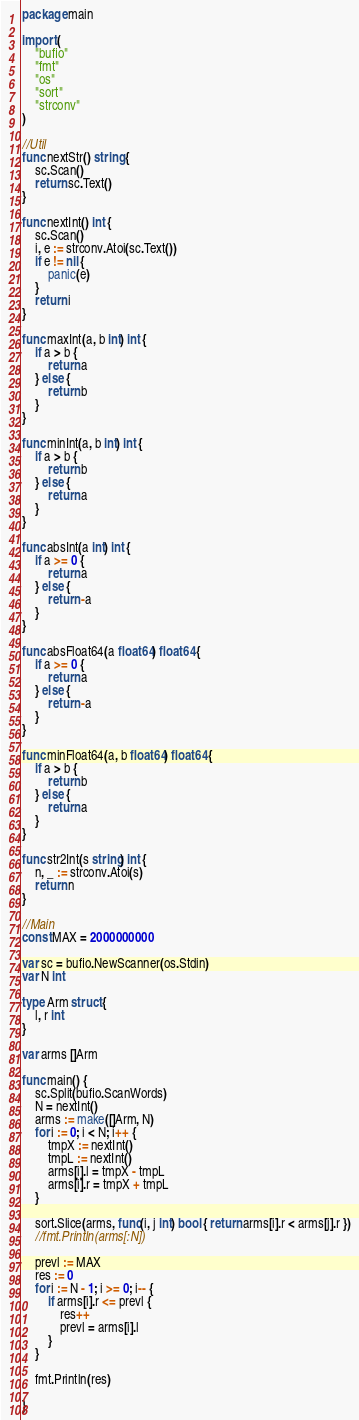<code> <loc_0><loc_0><loc_500><loc_500><_Go_>package main

import (
	"bufio"
	"fmt"
	"os"
	"sort"
	"strconv"
)

//Util
func nextStr() string {
	sc.Scan()
	return sc.Text()
}

func nextInt() int {
	sc.Scan()
	i, e := strconv.Atoi(sc.Text())
	if e != nil {
		panic(e)
	}
	return i
}

func maxInt(a, b int) int {
	if a > b {
		return a
	} else {
		return b
	}
}

func minInt(a, b int) int {
	if a > b {
		return b
	} else {
		return a
	}
}

func absInt(a int) int {
	if a >= 0 {
		return a
	} else {
		return -a
	}
}

func absFloat64(a float64) float64 {
	if a >= 0 {
		return a
	} else {
		return -a
	}
}

func minFloat64(a, b float64) float64 {
	if a > b {
		return b
	} else {
		return a
	}
}

func str2Int(s string) int {
	n, _ := strconv.Atoi(s)
	return n
}

//Main
const MAX = 2000000000

var sc = bufio.NewScanner(os.Stdin)
var N int

type Arm struct {
	l, r int
}

var arms []Arm

func main() {
	sc.Split(bufio.ScanWords)
	N = nextInt()
	arms := make([]Arm, N)
	for i := 0; i < N; i++ {
		tmpX := nextInt()
		tmpL := nextInt()
		arms[i].l = tmpX - tmpL
		arms[i].r = tmpX + tmpL
	}

	sort.Slice(arms, func(i, j int) bool { return arms[i].r < arms[j].r })
	//fmt.Println(arms[:N])

	prevl := MAX
	res := 0
	for i := N - 1; i >= 0; i-- {
		if arms[i].r <= prevl {
			res++
			prevl = arms[i].l
		}
	}

	fmt.Println(res)

}
</code> 